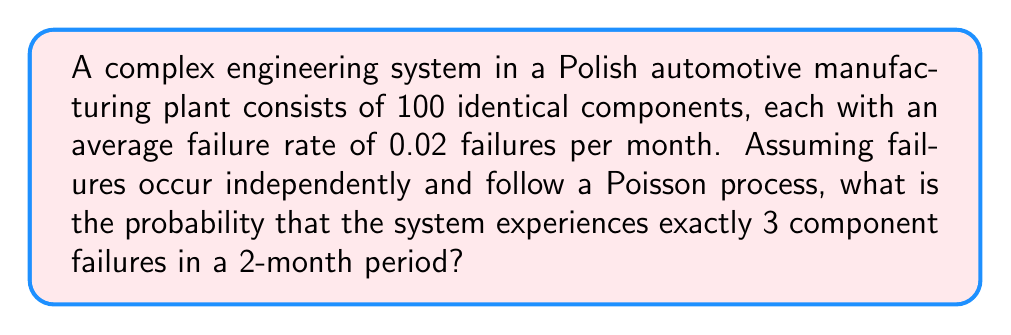Help me with this question. Let's approach this step-by-step:

1) First, we need to determine the rate parameter (λ) for the entire system over the 2-month period:
   
   λ = (number of components) × (failure rate per component) × (time period)
   λ = 100 × 0.02 × 2 = 4

2) Now, we can use the Poisson probability mass function to calculate the probability of exactly 3 failures:

   $$P(X = k) = \frac{e^{-λ} λ^k}{k!}$$

   Where:
   - e is Euler's number (≈ 2.71828)
   - λ is the rate parameter (4 in this case)
   - k is the number of occurrences (3 in this case)

3) Substituting our values:

   $$P(X = 3) = \frac{e^{-4} 4^3}{3!}$$

4) Let's calculate this step-by-step:
   
   $$P(X = 3) = \frac{e^{-4} \times 64}{6}$$
   
   $$= \frac{0.0183 \times 64}{6}$$
   
   $$= \frac{1.1712}{6}$$
   
   $$= 0.1952$$

5) Therefore, the probability of exactly 3 failures in a 2-month period is approximately 0.1952 or 19.52%.
Answer: 0.1952 